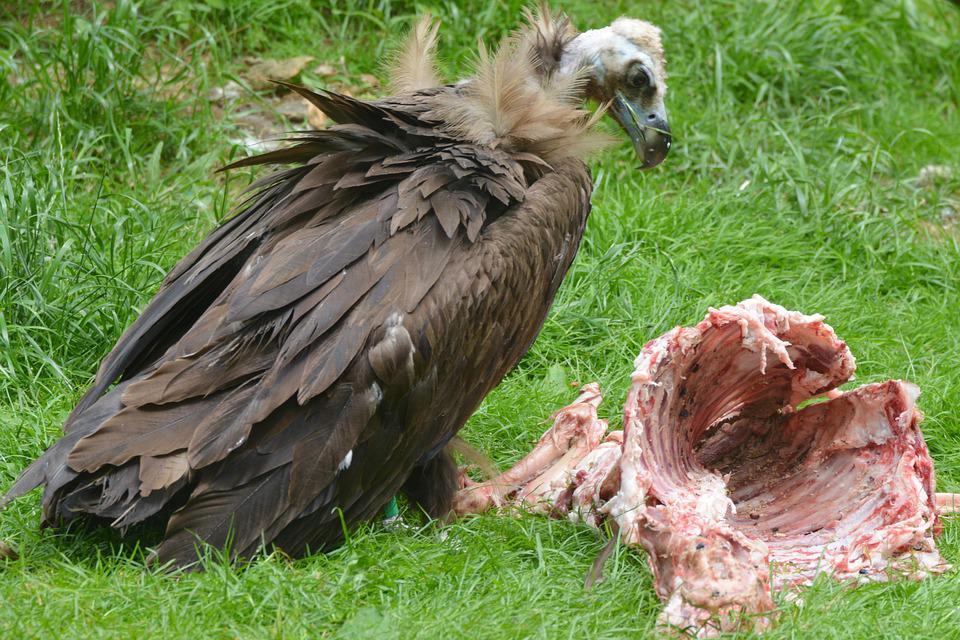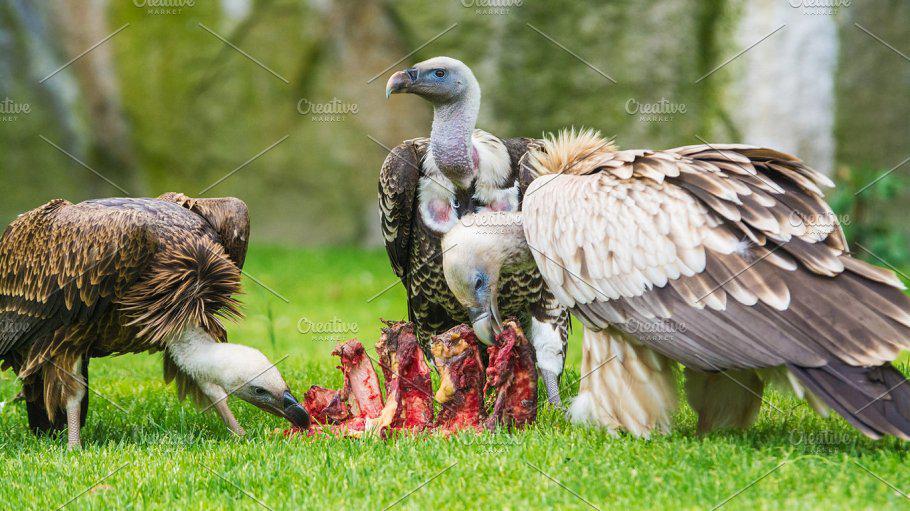The first image is the image on the left, the second image is the image on the right. For the images shown, is this caption "The right image contains no more than one large bird." true? Answer yes or no. No. The first image is the image on the left, the second image is the image on the right. Examine the images to the left and right. Is the description "An image contains only one live vulture, which is standing next to some type of carcass, but not on top of it." accurate? Answer yes or no. Yes. 